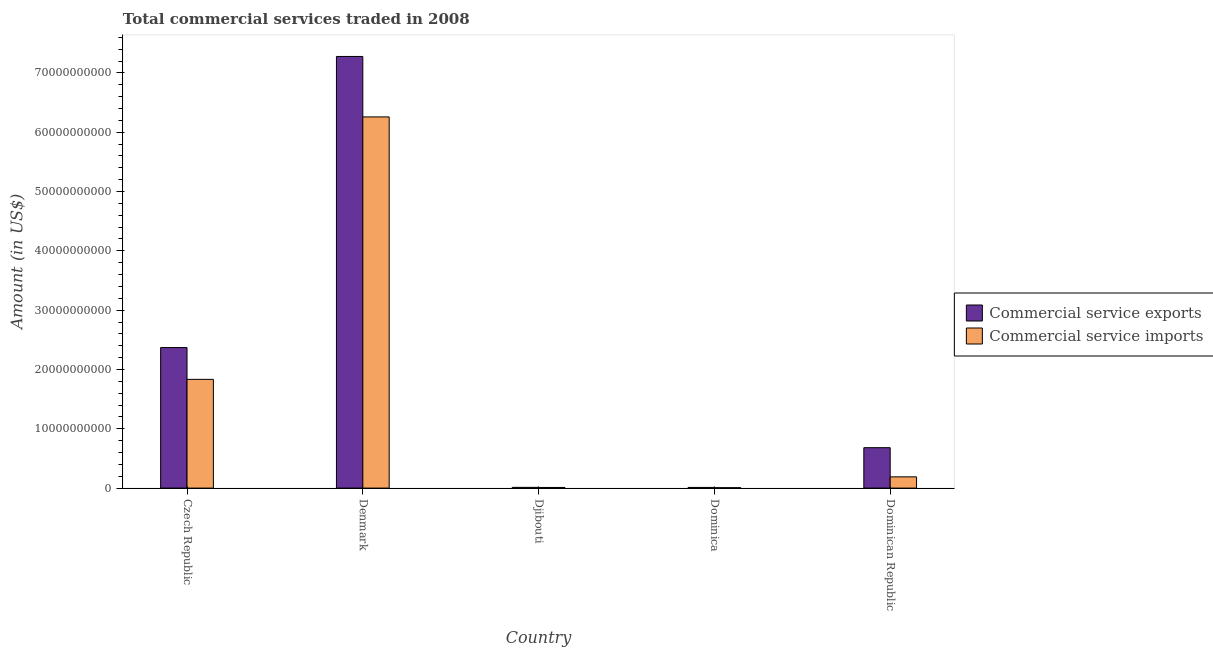How many different coloured bars are there?
Give a very brief answer. 2. How many groups of bars are there?
Give a very brief answer. 5. Are the number of bars on each tick of the X-axis equal?
Keep it short and to the point. Yes. How many bars are there on the 1st tick from the right?
Offer a very short reply. 2. What is the label of the 5th group of bars from the left?
Your answer should be very brief. Dominican Republic. In how many cases, is the number of bars for a given country not equal to the number of legend labels?
Make the answer very short. 0. What is the amount of commercial service exports in Djibouti?
Offer a very short reply. 1.23e+08. Across all countries, what is the maximum amount of commercial service exports?
Provide a succinct answer. 7.28e+1. Across all countries, what is the minimum amount of commercial service imports?
Provide a succinct answer. 6.89e+07. In which country was the amount of commercial service imports maximum?
Ensure brevity in your answer.  Denmark. In which country was the amount of commercial service exports minimum?
Your response must be concise. Dominica. What is the total amount of commercial service imports in the graph?
Your answer should be very brief. 8.30e+1. What is the difference between the amount of commercial service exports in Dominica and that in Dominican Republic?
Offer a terse response. -6.70e+09. What is the difference between the amount of commercial service imports in Denmark and the amount of commercial service exports in Djibouti?
Ensure brevity in your answer.  6.25e+1. What is the average amount of commercial service imports per country?
Provide a short and direct response. 1.66e+1. What is the difference between the amount of commercial service imports and amount of commercial service exports in Dominican Republic?
Provide a short and direct response. -4.92e+09. What is the ratio of the amount of commercial service exports in Denmark to that in Dominica?
Keep it short and to the point. 656.12. Is the amount of commercial service exports in Denmark less than that in Dominican Republic?
Keep it short and to the point. No. Is the difference between the amount of commercial service exports in Djibouti and Dominican Republic greater than the difference between the amount of commercial service imports in Djibouti and Dominican Republic?
Give a very brief answer. No. What is the difference between the highest and the second highest amount of commercial service imports?
Your response must be concise. 4.42e+1. What is the difference between the highest and the lowest amount of commercial service imports?
Make the answer very short. 6.25e+1. Is the sum of the amount of commercial service imports in Djibouti and Dominica greater than the maximum amount of commercial service exports across all countries?
Offer a terse response. No. What does the 1st bar from the left in Czech Republic represents?
Offer a very short reply. Commercial service exports. What does the 1st bar from the right in Dominican Republic represents?
Offer a very short reply. Commercial service imports. How many bars are there?
Your answer should be very brief. 10. Are all the bars in the graph horizontal?
Your answer should be compact. No. What is the difference between two consecutive major ticks on the Y-axis?
Make the answer very short. 1.00e+1. Does the graph contain any zero values?
Your response must be concise. No. Where does the legend appear in the graph?
Provide a short and direct response. Center right. How are the legend labels stacked?
Ensure brevity in your answer.  Vertical. What is the title of the graph?
Provide a short and direct response. Total commercial services traded in 2008. What is the label or title of the X-axis?
Offer a very short reply. Country. What is the Amount (in US$) in Commercial service exports in Czech Republic?
Provide a succinct answer. 2.37e+1. What is the Amount (in US$) of Commercial service imports in Czech Republic?
Provide a succinct answer. 1.83e+1. What is the Amount (in US$) in Commercial service exports in Denmark?
Your response must be concise. 7.28e+1. What is the Amount (in US$) in Commercial service imports in Denmark?
Your response must be concise. 6.26e+1. What is the Amount (in US$) in Commercial service exports in Djibouti?
Make the answer very short. 1.23e+08. What is the Amount (in US$) of Commercial service imports in Djibouti?
Make the answer very short. 1.08e+08. What is the Amount (in US$) of Commercial service exports in Dominica?
Your answer should be compact. 1.11e+08. What is the Amount (in US$) of Commercial service imports in Dominica?
Provide a short and direct response. 6.89e+07. What is the Amount (in US$) in Commercial service exports in Dominican Republic?
Your answer should be very brief. 6.81e+09. What is the Amount (in US$) in Commercial service imports in Dominican Republic?
Give a very brief answer. 1.89e+09. Across all countries, what is the maximum Amount (in US$) in Commercial service exports?
Provide a short and direct response. 7.28e+1. Across all countries, what is the maximum Amount (in US$) in Commercial service imports?
Keep it short and to the point. 6.26e+1. Across all countries, what is the minimum Amount (in US$) of Commercial service exports?
Your answer should be very brief. 1.11e+08. Across all countries, what is the minimum Amount (in US$) in Commercial service imports?
Provide a succinct answer. 6.89e+07. What is the total Amount (in US$) of Commercial service exports in the graph?
Keep it short and to the point. 1.04e+11. What is the total Amount (in US$) in Commercial service imports in the graph?
Provide a succinct answer. 8.30e+1. What is the difference between the Amount (in US$) of Commercial service exports in Czech Republic and that in Denmark?
Keep it short and to the point. -4.91e+1. What is the difference between the Amount (in US$) of Commercial service imports in Czech Republic and that in Denmark?
Offer a terse response. -4.42e+1. What is the difference between the Amount (in US$) in Commercial service exports in Czech Republic and that in Djibouti?
Make the answer very short. 2.36e+1. What is the difference between the Amount (in US$) of Commercial service imports in Czech Republic and that in Djibouti?
Offer a very short reply. 1.82e+1. What is the difference between the Amount (in US$) of Commercial service exports in Czech Republic and that in Dominica?
Offer a very short reply. 2.36e+1. What is the difference between the Amount (in US$) of Commercial service imports in Czech Republic and that in Dominica?
Provide a short and direct response. 1.83e+1. What is the difference between the Amount (in US$) in Commercial service exports in Czech Republic and that in Dominican Republic?
Your answer should be very brief. 1.69e+1. What is the difference between the Amount (in US$) of Commercial service imports in Czech Republic and that in Dominican Republic?
Ensure brevity in your answer.  1.64e+1. What is the difference between the Amount (in US$) in Commercial service exports in Denmark and that in Djibouti?
Offer a very short reply. 7.27e+1. What is the difference between the Amount (in US$) of Commercial service imports in Denmark and that in Djibouti?
Your response must be concise. 6.25e+1. What is the difference between the Amount (in US$) in Commercial service exports in Denmark and that in Dominica?
Ensure brevity in your answer.  7.27e+1. What is the difference between the Amount (in US$) of Commercial service imports in Denmark and that in Dominica?
Offer a terse response. 6.25e+1. What is the difference between the Amount (in US$) of Commercial service exports in Denmark and that in Dominican Republic?
Offer a very short reply. 6.60e+1. What is the difference between the Amount (in US$) in Commercial service imports in Denmark and that in Dominican Republic?
Provide a succinct answer. 6.07e+1. What is the difference between the Amount (in US$) in Commercial service exports in Djibouti and that in Dominica?
Offer a terse response. 1.20e+07. What is the difference between the Amount (in US$) of Commercial service imports in Djibouti and that in Dominica?
Offer a very short reply. 3.87e+07. What is the difference between the Amount (in US$) of Commercial service exports in Djibouti and that in Dominican Republic?
Give a very brief answer. -6.69e+09. What is the difference between the Amount (in US$) in Commercial service imports in Djibouti and that in Dominican Republic?
Make the answer very short. -1.79e+09. What is the difference between the Amount (in US$) in Commercial service exports in Dominica and that in Dominican Republic?
Provide a succinct answer. -6.70e+09. What is the difference between the Amount (in US$) in Commercial service imports in Dominica and that in Dominican Republic?
Your answer should be compact. -1.83e+09. What is the difference between the Amount (in US$) of Commercial service exports in Czech Republic and the Amount (in US$) of Commercial service imports in Denmark?
Ensure brevity in your answer.  -3.89e+1. What is the difference between the Amount (in US$) of Commercial service exports in Czech Republic and the Amount (in US$) of Commercial service imports in Djibouti?
Keep it short and to the point. 2.36e+1. What is the difference between the Amount (in US$) in Commercial service exports in Czech Republic and the Amount (in US$) in Commercial service imports in Dominica?
Provide a short and direct response. 2.36e+1. What is the difference between the Amount (in US$) of Commercial service exports in Czech Republic and the Amount (in US$) of Commercial service imports in Dominican Republic?
Your answer should be compact. 2.18e+1. What is the difference between the Amount (in US$) in Commercial service exports in Denmark and the Amount (in US$) in Commercial service imports in Djibouti?
Provide a short and direct response. 7.27e+1. What is the difference between the Amount (in US$) in Commercial service exports in Denmark and the Amount (in US$) in Commercial service imports in Dominica?
Your answer should be compact. 7.27e+1. What is the difference between the Amount (in US$) in Commercial service exports in Denmark and the Amount (in US$) in Commercial service imports in Dominican Republic?
Provide a short and direct response. 7.09e+1. What is the difference between the Amount (in US$) in Commercial service exports in Djibouti and the Amount (in US$) in Commercial service imports in Dominica?
Provide a short and direct response. 5.40e+07. What is the difference between the Amount (in US$) in Commercial service exports in Djibouti and the Amount (in US$) in Commercial service imports in Dominican Republic?
Offer a terse response. -1.77e+09. What is the difference between the Amount (in US$) in Commercial service exports in Dominica and the Amount (in US$) in Commercial service imports in Dominican Republic?
Give a very brief answer. -1.78e+09. What is the average Amount (in US$) in Commercial service exports per country?
Your answer should be very brief. 2.07e+1. What is the average Amount (in US$) of Commercial service imports per country?
Give a very brief answer. 1.66e+1. What is the difference between the Amount (in US$) of Commercial service exports and Amount (in US$) of Commercial service imports in Czech Republic?
Give a very brief answer. 5.36e+09. What is the difference between the Amount (in US$) in Commercial service exports and Amount (in US$) in Commercial service imports in Denmark?
Your answer should be very brief. 1.02e+1. What is the difference between the Amount (in US$) in Commercial service exports and Amount (in US$) in Commercial service imports in Djibouti?
Make the answer very short. 1.54e+07. What is the difference between the Amount (in US$) of Commercial service exports and Amount (in US$) of Commercial service imports in Dominica?
Keep it short and to the point. 4.21e+07. What is the difference between the Amount (in US$) of Commercial service exports and Amount (in US$) of Commercial service imports in Dominican Republic?
Give a very brief answer. 4.92e+09. What is the ratio of the Amount (in US$) of Commercial service exports in Czech Republic to that in Denmark?
Provide a succinct answer. 0.33. What is the ratio of the Amount (in US$) of Commercial service imports in Czech Republic to that in Denmark?
Your answer should be very brief. 0.29. What is the ratio of the Amount (in US$) of Commercial service exports in Czech Republic to that in Djibouti?
Offer a very short reply. 192.79. What is the ratio of the Amount (in US$) of Commercial service imports in Czech Republic to that in Djibouti?
Give a very brief answer. 170.49. What is the ratio of the Amount (in US$) in Commercial service exports in Czech Republic to that in Dominica?
Keep it short and to the point. 213.62. What is the ratio of the Amount (in US$) of Commercial service imports in Czech Republic to that in Dominica?
Give a very brief answer. 266.25. What is the ratio of the Amount (in US$) in Commercial service exports in Czech Republic to that in Dominican Republic?
Your answer should be compact. 3.48. What is the ratio of the Amount (in US$) in Commercial service imports in Czech Republic to that in Dominican Republic?
Offer a terse response. 9.68. What is the ratio of the Amount (in US$) in Commercial service exports in Denmark to that in Djibouti?
Give a very brief answer. 592.14. What is the ratio of the Amount (in US$) of Commercial service imports in Denmark to that in Djibouti?
Give a very brief answer. 581.99. What is the ratio of the Amount (in US$) of Commercial service exports in Denmark to that in Dominica?
Your answer should be compact. 656.12. What is the ratio of the Amount (in US$) in Commercial service imports in Denmark to that in Dominica?
Provide a succinct answer. 908.88. What is the ratio of the Amount (in US$) in Commercial service exports in Denmark to that in Dominican Republic?
Make the answer very short. 10.68. What is the ratio of the Amount (in US$) of Commercial service imports in Denmark to that in Dominican Republic?
Provide a succinct answer. 33.03. What is the ratio of the Amount (in US$) in Commercial service exports in Djibouti to that in Dominica?
Your answer should be compact. 1.11. What is the ratio of the Amount (in US$) in Commercial service imports in Djibouti to that in Dominica?
Provide a short and direct response. 1.56. What is the ratio of the Amount (in US$) in Commercial service exports in Djibouti to that in Dominican Republic?
Your answer should be very brief. 0.02. What is the ratio of the Amount (in US$) of Commercial service imports in Djibouti to that in Dominican Republic?
Provide a short and direct response. 0.06. What is the ratio of the Amount (in US$) in Commercial service exports in Dominica to that in Dominican Republic?
Your answer should be compact. 0.02. What is the ratio of the Amount (in US$) in Commercial service imports in Dominica to that in Dominican Republic?
Provide a short and direct response. 0.04. What is the difference between the highest and the second highest Amount (in US$) in Commercial service exports?
Offer a very short reply. 4.91e+1. What is the difference between the highest and the second highest Amount (in US$) in Commercial service imports?
Offer a very short reply. 4.42e+1. What is the difference between the highest and the lowest Amount (in US$) of Commercial service exports?
Give a very brief answer. 7.27e+1. What is the difference between the highest and the lowest Amount (in US$) of Commercial service imports?
Your response must be concise. 6.25e+1. 